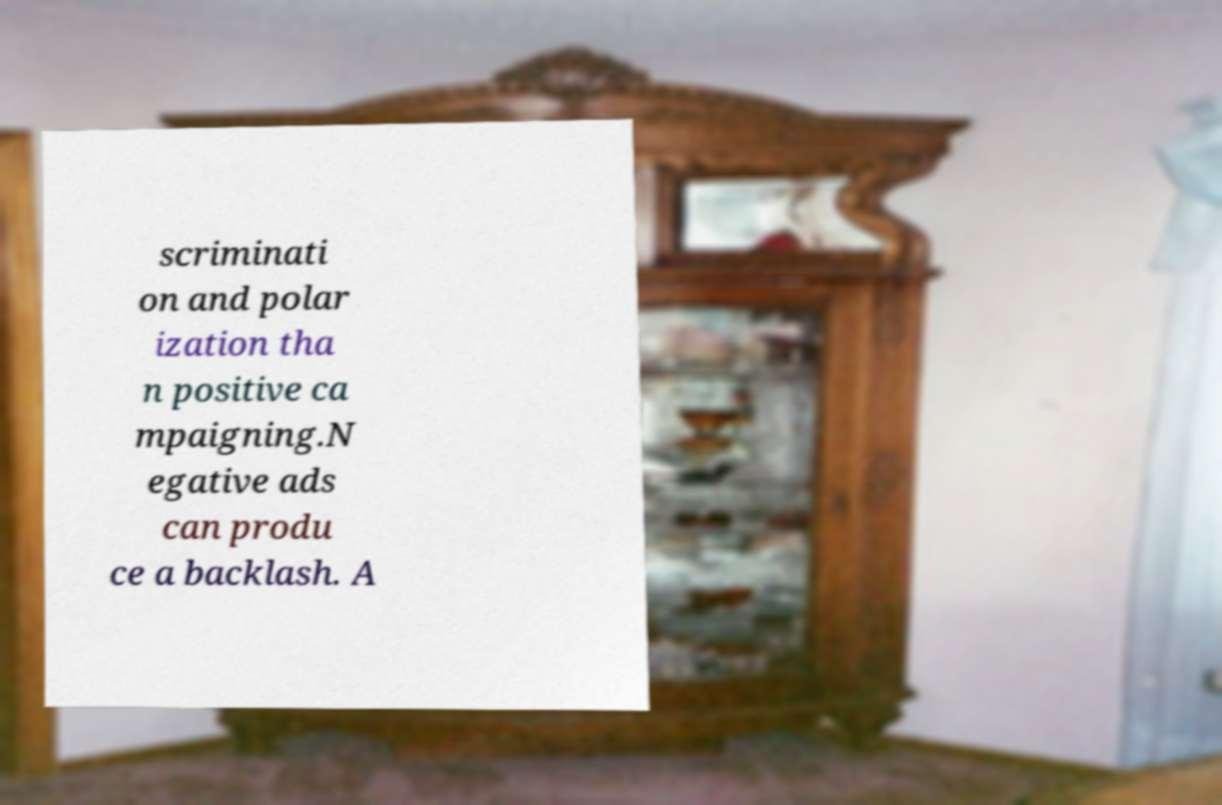Please identify and transcribe the text found in this image. scriminati on and polar ization tha n positive ca mpaigning.N egative ads can produ ce a backlash. A 